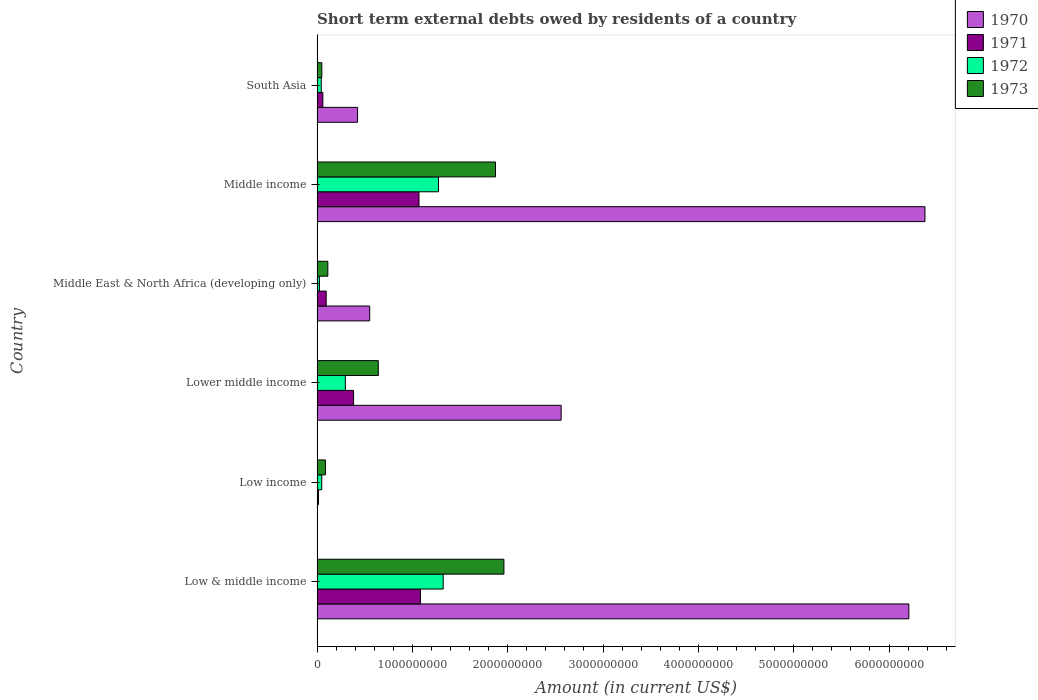How many different coloured bars are there?
Your response must be concise. 4. How many groups of bars are there?
Your answer should be compact. 6. Are the number of bars per tick equal to the number of legend labels?
Make the answer very short. No. How many bars are there on the 6th tick from the top?
Provide a short and direct response. 4. How many bars are there on the 6th tick from the bottom?
Give a very brief answer. 4. What is the amount of short-term external debts owed by residents in 1972 in Middle income?
Keep it short and to the point. 1.27e+09. Across all countries, what is the maximum amount of short-term external debts owed by residents in 1973?
Your answer should be very brief. 1.96e+09. Across all countries, what is the minimum amount of short-term external debts owed by residents in 1973?
Your response must be concise. 5.00e+07. In which country was the amount of short-term external debts owed by residents in 1970 maximum?
Offer a terse response. Middle income. What is the total amount of short-term external debts owed by residents in 1972 in the graph?
Make the answer very short. 3.01e+09. What is the difference between the amount of short-term external debts owed by residents in 1970 in Low & middle income and that in South Asia?
Offer a very short reply. 5.78e+09. What is the difference between the amount of short-term external debts owed by residents in 1972 in South Asia and the amount of short-term external debts owed by residents in 1973 in Low income?
Provide a short and direct response. -4.44e+07. What is the average amount of short-term external debts owed by residents in 1971 per country?
Ensure brevity in your answer.  4.52e+08. What is the difference between the amount of short-term external debts owed by residents in 1970 and amount of short-term external debts owed by residents in 1971 in Middle income?
Your response must be concise. 5.31e+09. What is the ratio of the amount of short-term external debts owed by residents in 1971 in Low & middle income to that in Lower middle income?
Your answer should be very brief. 2.83. Is the amount of short-term external debts owed by residents in 1973 in Low & middle income less than that in South Asia?
Make the answer very short. No. Is the difference between the amount of short-term external debts owed by residents in 1970 in Low & middle income and Lower middle income greater than the difference between the amount of short-term external debts owed by residents in 1971 in Low & middle income and Lower middle income?
Ensure brevity in your answer.  Yes. What is the difference between the highest and the second highest amount of short-term external debts owed by residents in 1973?
Your answer should be very brief. 8.84e+07. What is the difference between the highest and the lowest amount of short-term external debts owed by residents in 1973?
Keep it short and to the point. 1.91e+09. Is the sum of the amount of short-term external debts owed by residents in 1973 in Low income and Middle East & North Africa (developing only) greater than the maximum amount of short-term external debts owed by residents in 1971 across all countries?
Provide a short and direct response. No. How many bars are there?
Your response must be concise. 23. Are all the bars in the graph horizontal?
Offer a terse response. Yes. How many countries are there in the graph?
Offer a very short reply. 6. What is the difference between two consecutive major ticks on the X-axis?
Your response must be concise. 1.00e+09. Does the graph contain grids?
Offer a very short reply. No. Where does the legend appear in the graph?
Your answer should be very brief. Top right. How are the legend labels stacked?
Ensure brevity in your answer.  Vertical. What is the title of the graph?
Offer a terse response. Short term external debts owed by residents of a country. What is the label or title of the Y-axis?
Your answer should be very brief. Country. What is the Amount (in current US$) of 1970 in Low & middle income?
Provide a short and direct response. 6.21e+09. What is the Amount (in current US$) in 1971 in Low & middle income?
Keep it short and to the point. 1.08e+09. What is the Amount (in current US$) in 1972 in Low & middle income?
Your response must be concise. 1.32e+09. What is the Amount (in current US$) in 1973 in Low & middle income?
Provide a short and direct response. 1.96e+09. What is the Amount (in current US$) in 1970 in Low income?
Your answer should be very brief. 0. What is the Amount (in current US$) of 1971 in Low income?
Provide a succinct answer. 1.54e+07. What is the Amount (in current US$) in 1972 in Low income?
Ensure brevity in your answer.  4.94e+07. What is the Amount (in current US$) in 1973 in Low income?
Ensure brevity in your answer.  8.84e+07. What is the Amount (in current US$) of 1970 in Lower middle income?
Give a very brief answer. 2.56e+09. What is the Amount (in current US$) in 1971 in Lower middle income?
Give a very brief answer. 3.83e+08. What is the Amount (in current US$) in 1972 in Lower middle income?
Keep it short and to the point. 2.97e+08. What is the Amount (in current US$) in 1973 in Lower middle income?
Your response must be concise. 6.43e+08. What is the Amount (in current US$) of 1970 in Middle East & North Africa (developing only)?
Your answer should be compact. 5.52e+08. What is the Amount (in current US$) of 1971 in Middle East & North Africa (developing only)?
Provide a succinct answer. 9.60e+07. What is the Amount (in current US$) in 1972 in Middle East & North Africa (developing only)?
Offer a very short reply. 2.50e+07. What is the Amount (in current US$) in 1973 in Middle East & North Africa (developing only)?
Your answer should be very brief. 1.13e+08. What is the Amount (in current US$) of 1970 in Middle income?
Provide a short and direct response. 6.38e+09. What is the Amount (in current US$) in 1971 in Middle income?
Your answer should be very brief. 1.07e+09. What is the Amount (in current US$) of 1972 in Middle income?
Your answer should be very brief. 1.27e+09. What is the Amount (in current US$) of 1973 in Middle income?
Offer a terse response. 1.87e+09. What is the Amount (in current US$) of 1970 in South Asia?
Offer a terse response. 4.25e+08. What is the Amount (in current US$) of 1971 in South Asia?
Your answer should be very brief. 6.10e+07. What is the Amount (in current US$) of 1972 in South Asia?
Keep it short and to the point. 4.40e+07. Across all countries, what is the maximum Amount (in current US$) of 1970?
Provide a short and direct response. 6.38e+09. Across all countries, what is the maximum Amount (in current US$) of 1971?
Your answer should be compact. 1.08e+09. Across all countries, what is the maximum Amount (in current US$) in 1972?
Ensure brevity in your answer.  1.32e+09. Across all countries, what is the maximum Amount (in current US$) of 1973?
Make the answer very short. 1.96e+09. Across all countries, what is the minimum Amount (in current US$) in 1971?
Ensure brevity in your answer.  1.54e+07. Across all countries, what is the minimum Amount (in current US$) of 1972?
Keep it short and to the point. 2.50e+07. What is the total Amount (in current US$) of 1970 in the graph?
Provide a succinct answer. 1.61e+1. What is the total Amount (in current US$) in 1971 in the graph?
Give a very brief answer. 2.71e+09. What is the total Amount (in current US$) in 1972 in the graph?
Your answer should be compact. 3.01e+09. What is the total Amount (in current US$) of 1973 in the graph?
Provide a succinct answer. 4.73e+09. What is the difference between the Amount (in current US$) in 1971 in Low & middle income and that in Low income?
Your response must be concise. 1.07e+09. What is the difference between the Amount (in current US$) in 1972 in Low & middle income and that in Low income?
Your response must be concise. 1.27e+09. What is the difference between the Amount (in current US$) in 1973 in Low & middle income and that in Low income?
Keep it short and to the point. 1.87e+09. What is the difference between the Amount (in current US$) in 1970 in Low & middle income and that in Lower middle income?
Provide a succinct answer. 3.65e+09. What is the difference between the Amount (in current US$) in 1971 in Low & middle income and that in Lower middle income?
Ensure brevity in your answer.  7.01e+08. What is the difference between the Amount (in current US$) in 1972 in Low & middle income and that in Lower middle income?
Offer a terse response. 1.03e+09. What is the difference between the Amount (in current US$) in 1973 in Low & middle income and that in Lower middle income?
Give a very brief answer. 1.32e+09. What is the difference between the Amount (in current US$) in 1970 in Low & middle income and that in Middle East & North Africa (developing only)?
Provide a succinct answer. 5.66e+09. What is the difference between the Amount (in current US$) in 1971 in Low & middle income and that in Middle East & North Africa (developing only)?
Give a very brief answer. 9.89e+08. What is the difference between the Amount (in current US$) of 1972 in Low & middle income and that in Middle East & North Africa (developing only)?
Give a very brief answer. 1.30e+09. What is the difference between the Amount (in current US$) in 1973 in Low & middle income and that in Middle East & North Africa (developing only)?
Offer a terse response. 1.85e+09. What is the difference between the Amount (in current US$) in 1970 in Low & middle income and that in Middle income?
Keep it short and to the point. -1.69e+08. What is the difference between the Amount (in current US$) in 1971 in Low & middle income and that in Middle income?
Keep it short and to the point. 1.54e+07. What is the difference between the Amount (in current US$) in 1972 in Low & middle income and that in Middle income?
Offer a very short reply. 4.94e+07. What is the difference between the Amount (in current US$) in 1973 in Low & middle income and that in Middle income?
Provide a succinct answer. 8.84e+07. What is the difference between the Amount (in current US$) of 1970 in Low & middle income and that in South Asia?
Ensure brevity in your answer.  5.78e+09. What is the difference between the Amount (in current US$) of 1971 in Low & middle income and that in South Asia?
Provide a succinct answer. 1.02e+09. What is the difference between the Amount (in current US$) of 1972 in Low & middle income and that in South Asia?
Keep it short and to the point. 1.28e+09. What is the difference between the Amount (in current US$) in 1973 in Low & middle income and that in South Asia?
Offer a terse response. 1.91e+09. What is the difference between the Amount (in current US$) of 1971 in Low income and that in Lower middle income?
Keep it short and to the point. -3.68e+08. What is the difference between the Amount (in current US$) in 1972 in Low income and that in Lower middle income?
Provide a succinct answer. -2.47e+08. What is the difference between the Amount (in current US$) of 1973 in Low income and that in Lower middle income?
Your answer should be compact. -5.54e+08. What is the difference between the Amount (in current US$) of 1971 in Low income and that in Middle East & North Africa (developing only)?
Keep it short and to the point. -8.06e+07. What is the difference between the Amount (in current US$) of 1972 in Low income and that in Middle East & North Africa (developing only)?
Provide a short and direct response. 2.44e+07. What is the difference between the Amount (in current US$) of 1973 in Low income and that in Middle East & North Africa (developing only)?
Your answer should be very brief. -2.46e+07. What is the difference between the Amount (in current US$) of 1971 in Low income and that in Middle income?
Offer a terse response. -1.05e+09. What is the difference between the Amount (in current US$) of 1972 in Low income and that in Middle income?
Provide a short and direct response. -1.22e+09. What is the difference between the Amount (in current US$) in 1973 in Low income and that in Middle income?
Provide a short and direct response. -1.78e+09. What is the difference between the Amount (in current US$) in 1971 in Low income and that in South Asia?
Offer a very short reply. -4.56e+07. What is the difference between the Amount (in current US$) in 1972 in Low income and that in South Asia?
Make the answer very short. 5.35e+06. What is the difference between the Amount (in current US$) of 1973 in Low income and that in South Asia?
Keep it short and to the point. 3.84e+07. What is the difference between the Amount (in current US$) in 1970 in Lower middle income and that in Middle East & North Africa (developing only)?
Offer a terse response. 2.01e+09. What is the difference between the Amount (in current US$) of 1971 in Lower middle income and that in Middle East & North Africa (developing only)?
Offer a very short reply. 2.87e+08. What is the difference between the Amount (in current US$) in 1972 in Lower middle income and that in Middle East & North Africa (developing only)?
Offer a terse response. 2.72e+08. What is the difference between the Amount (in current US$) in 1973 in Lower middle income and that in Middle East & North Africa (developing only)?
Your response must be concise. 5.30e+08. What is the difference between the Amount (in current US$) in 1970 in Lower middle income and that in Middle income?
Offer a terse response. -3.82e+09. What is the difference between the Amount (in current US$) in 1971 in Lower middle income and that in Middle income?
Offer a very short reply. -6.86e+08. What is the difference between the Amount (in current US$) in 1972 in Lower middle income and that in Middle income?
Make the answer very short. -9.77e+08. What is the difference between the Amount (in current US$) of 1973 in Lower middle income and that in Middle income?
Your response must be concise. -1.23e+09. What is the difference between the Amount (in current US$) of 1970 in Lower middle income and that in South Asia?
Your answer should be compact. 2.14e+09. What is the difference between the Amount (in current US$) in 1971 in Lower middle income and that in South Asia?
Provide a short and direct response. 3.22e+08. What is the difference between the Amount (in current US$) of 1972 in Lower middle income and that in South Asia?
Keep it short and to the point. 2.53e+08. What is the difference between the Amount (in current US$) of 1973 in Lower middle income and that in South Asia?
Keep it short and to the point. 5.93e+08. What is the difference between the Amount (in current US$) of 1970 in Middle East & North Africa (developing only) and that in Middle income?
Keep it short and to the point. -5.83e+09. What is the difference between the Amount (in current US$) in 1971 in Middle East & North Africa (developing only) and that in Middle income?
Provide a short and direct response. -9.73e+08. What is the difference between the Amount (in current US$) in 1972 in Middle East & North Africa (developing only) and that in Middle income?
Your answer should be compact. -1.25e+09. What is the difference between the Amount (in current US$) in 1973 in Middle East & North Africa (developing only) and that in Middle income?
Provide a succinct answer. -1.76e+09. What is the difference between the Amount (in current US$) in 1970 in Middle East & North Africa (developing only) and that in South Asia?
Make the answer very short. 1.27e+08. What is the difference between the Amount (in current US$) of 1971 in Middle East & North Africa (developing only) and that in South Asia?
Keep it short and to the point. 3.50e+07. What is the difference between the Amount (in current US$) in 1972 in Middle East & North Africa (developing only) and that in South Asia?
Offer a terse response. -1.90e+07. What is the difference between the Amount (in current US$) in 1973 in Middle East & North Africa (developing only) and that in South Asia?
Ensure brevity in your answer.  6.30e+07. What is the difference between the Amount (in current US$) in 1970 in Middle income and that in South Asia?
Provide a succinct answer. 5.95e+09. What is the difference between the Amount (in current US$) of 1971 in Middle income and that in South Asia?
Make the answer very short. 1.01e+09. What is the difference between the Amount (in current US$) in 1972 in Middle income and that in South Asia?
Offer a terse response. 1.23e+09. What is the difference between the Amount (in current US$) of 1973 in Middle income and that in South Asia?
Offer a terse response. 1.82e+09. What is the difference between the Amount (in current US$) of 1970 in Low & middle income and the Amount (in current US$) of 1971 in Low income?
Offer a terse response. 6.19e+09. What is the difference between the Amount (in current US$) in 1970 in Low & middle income and the Amount (in current US$) in 1972 in Low income?
Your answer should be compact. 6.16e+09. What is the difference between the Amount (in current US$) of 1970 in Low & middle income and the Amount (in current US$) of 1973 in Low income?
Your answer should be compact. 6.12e+09. What is the difference between the Amount (in current US$) in 1971 in Low & middle income and the Amount (in current US$) in 1972 in Low income?
Ensure brevity in your answer.  1.04e+09. What is the difference between the Amount (in current US$) of 1971 in Low & middle income and the Amount (in current US$) of 1973 in Low income?
Provide a short and direct response. 9.96e+08. What is the difference between the Amount (in current US$) in 1972 in Low & middle income and the Amount (in current US$) in 1973 in Low income?
Your answer should be compact. 1.23e+09. What is the difference between the Amount (in current US$) in 1970 in Low & middle income and the Amount (in current US$) in 1971 in Lower middle income?
Provide a short and direct response. 5.83e+09. What is the difference between the Amount (in current US$) of 1970 in Low & middle income and the Amount (in current US$) of 1972 in Lower middle income?
Ensure brevity in your answer.  5.91e+09. What is the difference between the Amount (in current US$) in 1970 in Low & middle income and the Amount (in current US$) in 1973 in Lower middle income?
Provide a short and direct response. 5.57e+09. What is the difference between the Amount (in current US$) in 1971 in Low & middle income and the Amount (in current US$) in 1972 in Lower middle income?
Offer a very short reply. 7.88e+08. What is the difference between the Amount (in current US$) in 1971 in Low & middle income and the Amount (in current US$) in 1973 in Lower middle income?
Keep it short and to the point. 4.42e+08. What is the difference between the Amount (in current US$) in 1972 in Low & middle income and the Amount (in current US$) in 1973 in Lower middle income?
Your response must be concise. 6.80e+08. What is the difference between the Amount (in current US$) of 1970 in Low & middle income and the Amount (in current US$) of 1971 in Middle East & North Africa (developing only)?
Ensure brevity in your answer.  6.11e+09. What is the difference between the Amount (in current US$) of 1970 in Low & middle income and the Amount (in current US$) of 1972 in Middle East & North Africa (developing only)?
Provide a short and direct response. 6.18e+09. What is the difference between the Amount (in current US$) of 1970 in Low & middle income and the Amount (in current US$) of 1973 in Middle East & North Africa (developing only)?
Your answer should be compact. 6.10e+09. What is the difference between the Amount (in current US$) in 1971 in Low & middle income and the Amount (in current US$) in 1972 in Middle East & North Africa (developing only)?
Make the answer very short. 1.06e+09. What is the difference between the Amount (in current US$) of 1971 in Low & middle income and the Amount (in current US$) of 1973 in Middle East & North Africa (developing only)?
Make the answer very short. 9.72e+08. What is the difference between the Amount (in current US$) in 1972 in Low & middle income and the Amount (in current US$) in 1973 in Middle East & North Africa (developing only)?
Provide a succinct answer. 1.21e+09. What is the difference between the Amount (in current US$) in 1970 in Low & middle income and the Amount (in current US$) in 1971 in Middle income?
Make the answer very short. 5.14e+09. What is the difference between the Amount (in current US$) of 1970 in Low & middle income and the Amount (in current US$) of 1972 in Middle income?
Your response must be concise. 4.93e+09. What is the difference between the Amount (in current US$) in 1970 in Low & middle income and the Amount (in current US$) in 1973 in Middle income?
Provide a succinct answer. 4.34e+09. What is the difference between the Amount (in current US$) in 1971 in Low & middle income and the Amount (in current US$) in 1972 in Middle income?
Your response must be concise. -1.89e+08. What is the difference between the Amount (in current US$) in 1971 in Low & middle income and the Amount (in current US$) in 1973 in Middle income?
Your answer should be compact. -7.87e+08. What is the difference between the Amount (in current US$) in 1972 in Low & middle income and the Amount (in current US$) in 1973 in Middle income?
Provide a short and direct response. -5.49e+08. What is the difference between the Amount (in current US$) of 1970 in Low & middle income and the Amount (in current US$) of 1971 in South Asia?
Your answer should be compact. 6.15e+09. What is the difference between the Amount (in current US$) in 1970 in Low & middle income and the Amount (in current US$) in 1972 in South Asia?
Give a very brief answer. 6.16e+09. What is the difference between the Amount (in current US$) in 1970 in Low & middle income and the Amount (in current US$) in 1973 in South Asia?
Give a very brief answer. 6.16e+09. What is the difference between the Amount (in current US$) in 1971 in Low & middle income and the Amount (in current US$) in 1972 in South Asia?
Ensure brevity in your answer.  1.04e+09. What is the difference between the Amount (in current US$) in 1971 in Low & middle income and the Amount (in current US$) in 1973 in South Asia?
Make the answer very short. 1.03e+09. What is the difference between the Amount (in current US$) of 1972 in Low & middle income and the Amount (in current US$) of 1973 in South Asia?
Ensure brevity in your answer.  1.27e+09. What is the difference between the Amount (in current US$) of 1971 in Low income and the Amount (in current US$) of 1972 in Lower middle income?
Provide a short and direct response. -2.81e+08. What is the difference between the Amount (in current US$) of 1971 in Low income and the Amount (in current US$) of 1973 in Lower middle income?
Make the answer very short. -6.27e+08. What is the difference between the Amount (in current US$) in 1972 in Low income and the Amount (in current US$) in 1973 in Lower middle income?
Your answer should be very brief. -5.93e+08. What is the difference between the Amount (in current US$) in 1971 in Low income and the Amount (in current US$) in 1972 in Middle East & North Africa (developing only)?
Provide a succinct answer. -9.65e+06. What is the difference between the Amount (in current US$) of 1971 in Low income and the Amount (in current US$) of 1973 in Middle East & North Africa (developing only)?
Keep it short and to the point. -9.76e+07. What is the difference between the Amount (in current US$) in 1972 in Low income and the Amount (in current US$) in 1973 in Middle East & North Africa (developing only)?
Keep it short and to the point. -6.36e+07. What is the difference between the Amount (in current US$) in 1971 in Low income and the Amount (in current US$) in 1972 in Middle income?
Your answer should be very brief. -1.26e+09. What is the difference between the Amount (in current US$) in 1971 in Low income and the Amount (in current US$) in 1973 in Middle income?
Ensure brevity in your answer.  -1.86e+09. What is the difference between the Amount (in current US$) of 1972 in Low income and the Amount (in current US$) of 1973 in Middle income?
Offer a very short reply. -1.82e+09. What is the difference between the Amount (in current US$) in 1971 in Low income and the Amount (in current US$) in 1972 in South Asia?
Offer a very short reply. -2.86e+07. What is the difference between the Amount (in current US$) in 1971 in Low income and the Amount (in current US$) in 1973 in South Asia?
Offer a terse response. -3.46e+07. What is the difference between the Amount (in current US$) in 1972 in Low income and the Amount (in current US$) in 1973 in South Asia?
Keep it short and to the point. -6.46e+05. What is the difference between the Amount (in current US$) in 1970 in Lower middle income and the Amount (in current US$) in 1971 in Middle East & North Africa (developing only)?
Give a very brief answer. 2.46e+09. What is the difference between the Amount (in current US$) of 1970 in Lower middle income and the Amount (in current US$) of 1972 in Middle East & North Africa (developing only)?
Your response must be concise. 2.54e+09. What is the difference between the Amount (in current US$) in 1970 in Lower middle income and the Amount (in current US$) in 1973 in Middle East & North Africa (developing only)?
Provide a short and direct response. 2.45e+09. What is the difference between the Amount (in current US$) in 1971 in Lower middle income and the Amount (in current US$) in 1972 in Middle East & North Africa (developing only)?
Make the answer very short. 3.58e+08. What is the difference between the Amount (in current US$) in 1971 in Lower middle income and the Amount (in current US$) in 1973 in Middle East & North Africa (developing only)?
Make the answer very short. 2.70e+08. What is the difference between the Amount (in current US$) in 1972 in Lower middle income and the Amount (in current US$) in 1973 in Middle East & North Africa (developing only)?
Provide a short and direct response. 1.84e+08. What is the difference between the Amount (in current US$) of 1970 in Lower middle income and the Amount (in current US$) of 1971 in Middle income?
Make the answer very short. 1.49e+09. What is the difference between the Amount (in current US$) in 1970 in Lower middle income and the Amount (in current US$) in 1972 in Middle income?
Provide a succinct answer. 1.29e+09. What is the difference between the Amount (in current US$) in 1970 in Lower middle income and the Amount (in current US$) in 1973 in Middle income?
Provide a succinct answer. 6.89e+08. What is the difference between the Amount (in current US$) in 1971 in Lower middle income and the Amount (in current US$) in 1972 in Middle income?
Your answer should be compact. -8.91e+08. What is the difference between the Amount (in current US$) of 1971 in Lower middle income and the Amount (in current US$) of 1973 in Middle income?
Your answer should be very brief. -1.49e+09. What is the difference between the Amount (in current US$) of 1972 in Lower middle income and the Amount (in current US$) of 1973 in Middle income?
Your answer should be very brief. -1.58e+09. What is the difference between the Amount (in current US$) in 1970 in Lower middle income and the Amount (in current US$) in 1971 in South Asia?
Give a very brief answer. 2.50e+09. What is the difference between the Amount (in current US$) in 1970 in Lower middle income and the Amount (in current US$) in 1972 in South Asia?
Provide a short and direct response. 2.52e+09. What is the difference between the Amount (in current US$) in 1970 in Lower middle income and the Amount (in current US$) in 1973 in South Asia?
Ensure brevity in your answer.  2.51e+09. What is the difference between the Amount (in current US$) in 1971 in Lower middle income and the Amount (in current US$) in 1972 in South Asia?
Give a very brief answer. 3.39e+08. What is the difference between the Amount (in current US$) of 1971 in Lower middle income and the Amount (in current US$) of 1973 in South Asia?
Ensure brevity in your answer.  3.33e+08. What is the difference between the Amount (in current US$) in 1972 in Lower middle income and the Amount (in current US$) in 1973 in South Asia?
Offer a terse response. 2.47e+08. What is the difference between the Amount (in current US$) in 1970 in Middle East & North Africa (developing only) and the Amount (in current US$) in 1971 in Middle income?
Offer a very short reply. -5.17e+08. What is the difference between the Amount (in current US$) in 1970 in Middle East & North Africa (developing only) and the Amount (in current US$) in 1972 in Middle income?
Your answer should be very brief. -7.22e+08. What is the difference between the Amount (in current US$) of 1970 in Middle East & North Africa (developing only) and the Amount (in current US$) of 1973 in Middle income?
Offer a terse response. -1.32e+09. What is the difference between the Amount (in current US$) in 1971 in Middle East & North Africa (developing only) and the Amount (in current US$) in 1972 in Middle income?
Give a very brief answer. -1.18e+09. What is the difference between the Amount (in current US$) of 1971 in Middle East & North Africa (developing only) and the Amount (in current US$) of 1973 in Middle income?
Your response must be concise. -1.78e+09. What is the difference between the Amount (in current US$) of 1972 in Middle East & North Africa (developing only) and the Amount (in current US$) of 1973 in Middle income?
Keep it short and to the point. -1.85e+09. What is the difference between the Amount (in current US$) in 1970 in Middle East & North Africa (developing only) and the Amount (in current US$) in 1971 in South Asia?
Your response must be concise. 4.91e+08. What is the difference between the Amount (in current US$) in 1970 in Middle East & North Africa (developing only) and the Amount (in current US$) in 1972 in South Asia?
Keep it short and to the point. 5.08e+08. What is the difference between the Amount (in current US$) in 1970 in Middle East & North Africa (developing only) and the Amount (in current US$) in 1973 in South Asia?
Offer a very short reply. 5.02e+08. What is the difference between the Amount (in current US$) in 1971 in Middle East & North Africa (developing only) and the Amount (in current US$) in 1972 in South Asia?
Offer a terse response. 5.20e+07. What is the difference between the Amount (in current US$) of 1971 in Middle East & North Africa (developing only) and the Amount (in current US$) of 1973 in South Asia?
Ensure brevity in your answer.  4.60e+07. What is the difference between the Amount (in current US$) of 1972 in Middle East & North Africa (developing only) and the Amount (in current US$) of 1973 in South Asia?
Your answer should be very brief. -2.50e+07. What is the difference between the Amount (in current US$) in 1970 in Middle income and the Amount (in current US$) in 1971 in South Asia?
Your answer should be compact. 6.32e+09. What is the difference between the Amount (in current US$) of 1970 in Middle income and the Amount (in current US$) of 1972 in South Asia?
Your answer should be compact. 6.33e+09. What is the difference between the Amount (in current US$) in 1970 in Middle income and the Amount (in current US$) in 1973 in South Asia?
Ensure brevity in your answer.  6.33e+09. What is the difference between the Amount (in current US$) in 1971 in Middle income and the Amount (in current US$) in 1972 in South Asia?
Your answer should be very brief. 1.03e+09. What is the difference between the Amount (in current US$) of 1971 in Middle income and the Amount (in current US$) of 1973 in South Asia?
Keep it short and to the point. 1.02e+09. What is the difference between the Amount (in current US$) of 1972 in Middle income and the Amount (in current US$) of 1973 in South Asia?
Provide a short and direct response. 1.22e+09. What is the average Amount (in current US$) of 1970 per country?
Ensure brevity in your answer.  2.69e+09. What is the average Amount (in current US$) of 1971 per country?
Keep it short and to the point. 4.52e+08. What is the average Amount (in current US$) of 1972 per country?
Offer a terse response. 5.02e+08. What is the average Amount (in current US$) of 1973 per country?
Keep it short and to the point. 7.88e+08. What is the difference between the Amount (in current US$) of 1970 and Amount (in current US$) of 1971 in Low & middle income?
Offer a very short reply. 5.12e+09. What is the difference between the Amount (in current US$) of 1970 and Amount (in current US$) of 1972 in Low & middle income?
Give a very brief answer. 4.89e+09. What is the difference between the Amount (in current US$) in 1970 and Amount (in current US$) in 1973 in Low & middle income?
Keep it short and to the point. 4.25e+09. What is the difference between the Amount (in current US$) in 1971 and Amount (in current US$) in 1972 in Low & middle income?
Your answer should be very brief. -2.39e+08. What is the difference between the Amount (in current US$) of 1971 and Amount (in current US$) of 1973 in Low & middle income?
Your response must be concise. -8.76e+08. What is the difference between the Amount (in current US$) of 1972 and Amount (in current US$) of 1973 in Low & middle income?
Provide a succinct answer. -6.37e+08. What is the difference between the Amount (in current US$) in 1971 and Amount (in current US$) in 1972 in Low income?
Your answer should be very brief. -3.40e+07. What is the difference between the Amount (in current US$) in 1971 and Amount (in current US$) in 1973 in Low income?
Your response must be concise. -7.30e+07. What is the difference between the Amount (in current US$) of 1972 and Amount (in current US$) of 1973 in Low income?
Make the answer very short. -3.90e+07. What is the difference between the Amount (in current US$) in 1970 and Amount (in current US$) in 1971 in Lower middle income?
Your answer should be very brief. 2.18e+09. What is the difference between the Amount (in current US$) of 1970 and Amount (in current US$) of 1972 in Lower middle income?
Ensure brevity in your answer.  2.26e+09. What is the difference between the Amount (in current US$) in 1970 and Amount (in current US$) in 1973 in Lower middle income?
Keep it short and to the point. 1.92e+09. What is the difference between the Amount (in current US$) of 1971 and Amount (in current US$) of 1972 in Lower middle income?
Ensure brevity in your answer.  8.65e+07. What is the difference between the Amount (in current US$) in 1971 and Amount (in current US$) in 1973 in Lower middle income?
Give a very brief answer. -2.60e+08. What is the difference between the Amount (in current US$) of 1972 and Amount (in current US$) of 1973 in Lower middle income?
Your answer should be compact. -3.46e+08. What is the difference between the Amount (in current US$) of 1970 and Amount (in current US$) of 1971 in Middle East & North Africa (developing only)?
Give a very brief answer. 4.56e+08. What is the difference between the Amount (in current US$) of 1970 and Amount (in current US$) of 1972 in Middle East & North Africa (developing only)?
Ensure brevity in your answer.  5.27e+08. What is the difference between the Amount (in current US$) in 1970 and Amount (in current US$) in 1973 in Middle East & North Africa (developing only)?
Ensure brevity in your answer.  4.39e+08. What is the difference between the Amount (in current US$) of 1971 and Amount (in current US$) of 1972 in Middle East & North Africa (developing only)?
Provide a short and direct response. 7.10e+07. What is the difference between the Amount (in current US$) of 1971 and Amount (in current US$) of 1973 in Middle East & North Africa (developing only)?
Provide a succinct answer. -1.70e+07. What is the difference between the Amount (in current US$) in 1972 and Amount (in current US$) in 1973 in Middle East & North Africa (developing only)?
Provide a short and direct response. -8.80e+07. What is the difference between the Amount (in current US$) of 1970 and Amount (in current US$) of 1971 in Middle income?
Your answer should be very brief. 5.31e+09. What is the difference between the Amount (in current US$) in 1970 and Amount (in current US$) in 1972 in Middle income?
Offer a very short reply. 5.10e+09. What is the difference between the Amount (in current US$) of 1970 and Amount (in current US$) of 1973 in Middle income?
Your answer should be very brief. 4.51e+09. What is the difference between the Amount (in current US$) in 1971 and Amount (in current US$) in 1972 in Middle income?
Your answer should be very brief. -2.05e+08. What is the difference between the Amount (in current US$) in 1971 and Amount (in current US$) in 1973 in Middle income?
Make the answer very short. -8.03e+08. What is the difference between the Amount (in current US$) of 1972 and Amount (in current US$) of 1973 in Middle income?
Your response must be concise. -5.98e+08. What is the difference between the Amount (in current US$) in 1970 and Amount (in current US$) in 1971 in South Asia?
Offer a very short reply. 3.64e+08. What is the difference between the Amount (in current US$) in 1970 and Amount (in current US$) in 1972 in South Asia?
Your answer should be very brief. 3.81e+08. What is the difference between the Amount (in current US$) of 1970 and Amount (in current US$) of 1973 in South Asia?
Your answer should be very brief. 3.75e+08. What is the difference between the Amount (in current US$) in 1971 and Amount (in current US$) in 1972 in South Asia?
Offer a very short reply. 1.70e+07. What is the difference between the Amount (in current US$) in 1971 and Amount (in current US$) in 1973 in South Asia?
Give a very brief answer. 1.10e+07. What is the difference between the Amount (in current US$) in 1972 and Amount (in current US$) in 1973 in South Asia?
Your answer should be very brief. -6.00e+06. What is the ratio of the Amount (in current US$) in 1971 in Low & middle income to that in Low income?
Your response must be concise. 70.65. What is the ratio of the Amount (in current US$) of 1972 in Low & middle income to that in Low income?
Your answer should be compact. 26.81. What is the ratio of the Amount (in current US$) in 1973 in Low & middle income to that in Low income?
Your answer should be very brief. 22.19. What is the ratio of the Amount (in current US$) in 1970 in Low & middle income to that in Lower middle income?
Make the answer very short. 2.42. What is the ratio of the Amount (in current US$) in 1971 in Low & middle income to that in Lower middle income?
Give a very brief answer. 2.83. What is the ratio of the Amount (in current US$) of 1972 in Low & middle income to that in Lower middle income?
Provide a short and direct response. 4.46. What is the ratio of the Amount (in current US$) in 1973 in Low & middle income to that in Lower middle income?
Provide a succinct answer. 3.05. What is the ratio of the Amount (in current US$) in 1970 in Low & middle income to that in Middle East & North Africa (developing only)?
Give a very brief answer. 11.25. What is the ratio of the Amount (in current US$) in 1971 in Low & middle income to that in Middle East & North Africa (developing only)?
Keep it short and to the point. 11.3. What is the ratio of the Amount (in current US$) of 1972 in Low & middle income to that in Middle East & North Africa (developing only)?
Give a very brief answer. 52.93. What is the ratio of the Amount (in current US$) of 1973 in Low & middle income to that in Middle East & North Africa (developing only)?
Keep it short and to the point. 17.35. What is the ratio of the Amount (in current US$) of 1970 in Low & middle income to that in Middle income?
Ensure brevity in your answer.  0.97. What is the ratio of the Amount (in current US$) of 1971 in Low & middle income to that in Middle income?
Offer a very short reply. 1.01. What is the ratio of the Amount (in current US$) of 1972 in Low & middle income to that in Middle income?
Offer a very short reply. 1.04. What is the ratio of the Amount (in current US$) of 1973 in Low & middle income to that in Middle income?
Make the answer very short. 1.05. What is the ratio of the Amount (in current US$) of 1970 in Low & middle income to that in South Asia?
Your answer should be very brief. 14.61. What is the ratio of the Amount (in current US$) of 1971 in Low & middle income to that in South Asia?
Your response must be concise. 17.78. What is the ratio of the Amount (in current US$) of 1972 in Low & middle income to that in South Asia?
Offer a terse response. 30.08. What is the ratio of the Amount (in current US$) of 1973 in Low & middle income to that in South Asia?
Give a very brief answer. 39.21. What is the ratio of the Amount (in current US$) of 1971 in Low income to that in Lower middle income?
Give a very brief answer. 0.04. What is the ratio of the Amount (in current US$) in 1972 in Low income to that in Lower middle income?
Your answer should be compact. 0.17. What is the ratio of the Amount (in current US$) of 1973 in Low income to that in Lower middle income?
Provide a succinct answer. 0.14. What is the ratio of the Amount (in current US$) of 1971 in Low income to that in Middle East & North Africa (developing only)?
Your response must be concise. 0.16. What is the ratio of the Amount (in current US$) of 1972 in Low income to that in Middle East & North Africa (developing only)?
Offer a very short reply. 1.97. What is the ratio of the Amount (in current US$) in 1973 in Low income to that in Middle East & North Africa (developing only)?
Your answer should be compact. 0.78. What is the ratio of the Amount (in current US$) in 1971 in Low income to that in Middle income?
Make the answer very short. 0.01. What is the ratio of the Amount (in current US$) of 1972 in Low income to that in Middle income?
Give a very brief answer. 0.04. What is the ratio of the Amount (in current US$) in 1973 in Low income to that in Middle income?
Your answer should be compact. 0.05. What is the ratio of the Amount (in current US$) in 1971 in Low income to that in South Asia?
Provide a succinct answer. 0.25. What is the ratio of the Amount (in current US$) of 1972 in Low income to that in South Asia?
Your answer should be very brief. 1.12. What is the ratio of the Amount (in current US$) in 1973 in Low income to that in South Asia?
Provide a succinct answer. 1.77. What is the ratio of the Amount (in current US$) in 1970 in Lower middle income to that in Middle East & North Africa (developing only)?
Your answer should be very brief. 4.64. What is the ratio of the Amount (in current US$) in 1971 in Lower middle income to that in Middle East & North Africa (developing only)?
Your answer should be compact. 3.99. What is the ratio of the Amount (in current US$) in 1972 in Lower middle income to that in Middle East & North Africa (developing only)?
Ensure brevity in your answer.  11.87. What is the ratio of the Amount (in current US$) of 1973 in Lower middle income to that in Middle East & North Africa (developing only)?
Make the answer very short. 5.69. What is the ratio of the Amount (in current US$) of 1970 in Lower middle income to that in Middle income?
Provide a short and direct response. 0.4. What is the ratio of the Amount (in current US$) in 1971 in Lower middle income to that in Middle income?
Provide a short and direct response. 0.36. What is the ratio of the Amount (in current US$) of 1972 in Lower middle income to that in Middle income?
Offer a terse response. 0.23. What is the ratio of the Amount (in current US$) of 1973 in Lower middle income to that in Middle income?
Keep it short and to the point. 0.34. What is the ratio of the Amount (in current US$) in 1970 in Lower middle income to that in South Asia?
Offer a terse response. 6.03. What is the ratio of the Amount (in current US$) in 1971 in Lower middle income to that in South Asia?
Your answer should be compact. 6.28. What is the ratio of the Amount (in current US$) in 1972 in Lower middle income to that in South Asia?
Provide a short and direct response. 6.75. What is the ratio of the Amount (in current US$) in 1973 in Lower middle income to that in South Asia?
Provide a short and direct response. 12.86. What is the ratio of the Amount (in current US$) of 1970 in Middle East & North Africa (developing only) to that in Middle income?
Provide a succinct answer. 0.09. What is the ratio of the Amount (in current US$) of 1971 in Middle East & North Africa (developing only) to that in Middle income?
Give a very brief answer. 0.09. What is the ratio of the Amount (in current US$) in 1972 in Middle East & North Africa (developing only) to that in Middle income?
Your answer should be compact. 0.02. What is the ratio of the Amount (in current US$) of 1973 in Middle East & North Africa (developing only) to that in Middle income?
Keep it short and to the point. 0.06. What is the ratio of the Amount (in current US$) of 1970 in Middle East & North Africa (developing only) to that in South Asia?
Offer a terse response. 1.3. What is the ratio of the Amount (in current US$) of 1971 in Middle East & North Africa (developing only) to that in South Asia?
Provide a succinct answer. 1.57. What is the ratio of the Amount (in current US$) in 1972 in Middle East & North Africa (developing only) to that in South Asia?
Your answer should be compact. 0.57. What is the ratio of the Amount (in current US$) in 1973 in Middle East & North Africa (developing only) to that in South Asia?
Your answer should be very brief. 2.26. What is the ratio of the Amount (in current US$) of 1970 in Middle income to that in South Asia?
Your answer should be compact. 15.01. What is the ratio of the Amount (in current US$) in 1971 in Middle income to that in South Asia?
Give a very brief answer. 17.53. What is the ratio of the Amount (in current US$) of 1972 in Middle income to that in South Asia?
Give a very brief answer. 28.95. What is the ratio of the Amount (in current US$) in 1973 in Middle income to that in South Asia?
Keep it short and to the point. 37.44. What is the difference between the highest and the second highest Amount (in current US$) of 1970?
Your answer should be compact. 1.69e+08. What is the difference between the highest and the second highest Amount (in current US$) of 1971?
Your answer should be compact. 1.54e+07. What is the difference between the highest and the second highest Amount (in current US$) of 1972?
Offer a terse response. 4.94e+07. What is the difference between the highest and the second highest Amount (in current US$) of 1973?
Make the answer very short. 8.84e+07. What is the difference between the highest and the lowest Amount (in current US$) in 1970?
Your answer should be very brief. 6.38e+09. What is the difference between the highest and the lowest Amount (in current US$) of 1971?
Your response must be concise. 1.07e+09. What is the difference between the highest and the lowest Amount (in current US$) in 1972?
Keep it short and to the point. 1.30e+09. What is the difference between the highest and the lowest Amount (in current US$) in 1973?
Offer a very short reply. 1.91e+09. 